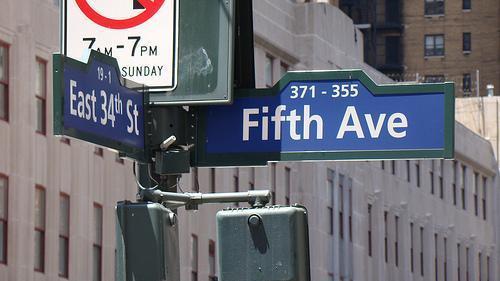How many signs are there?
Give a very brief answer. 2. 